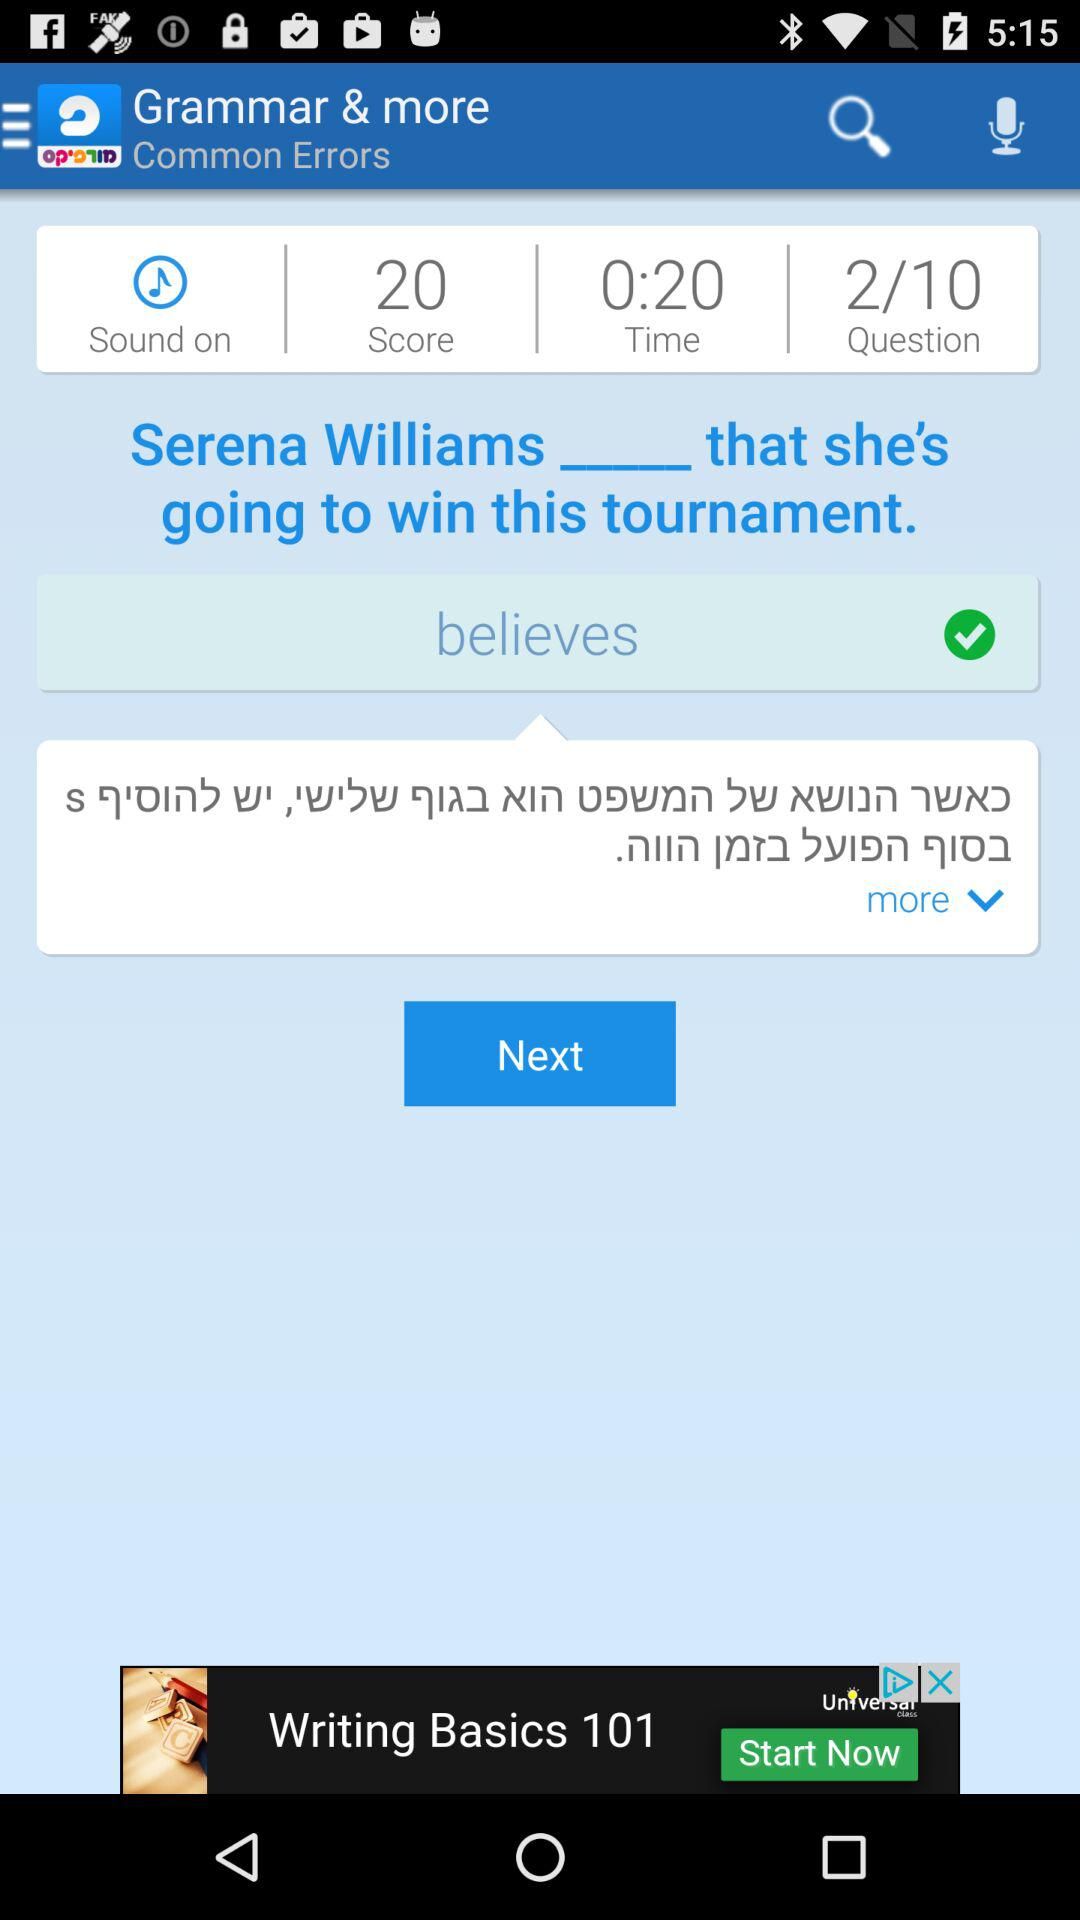What is the remaining time? The remaining time is 0:20. 